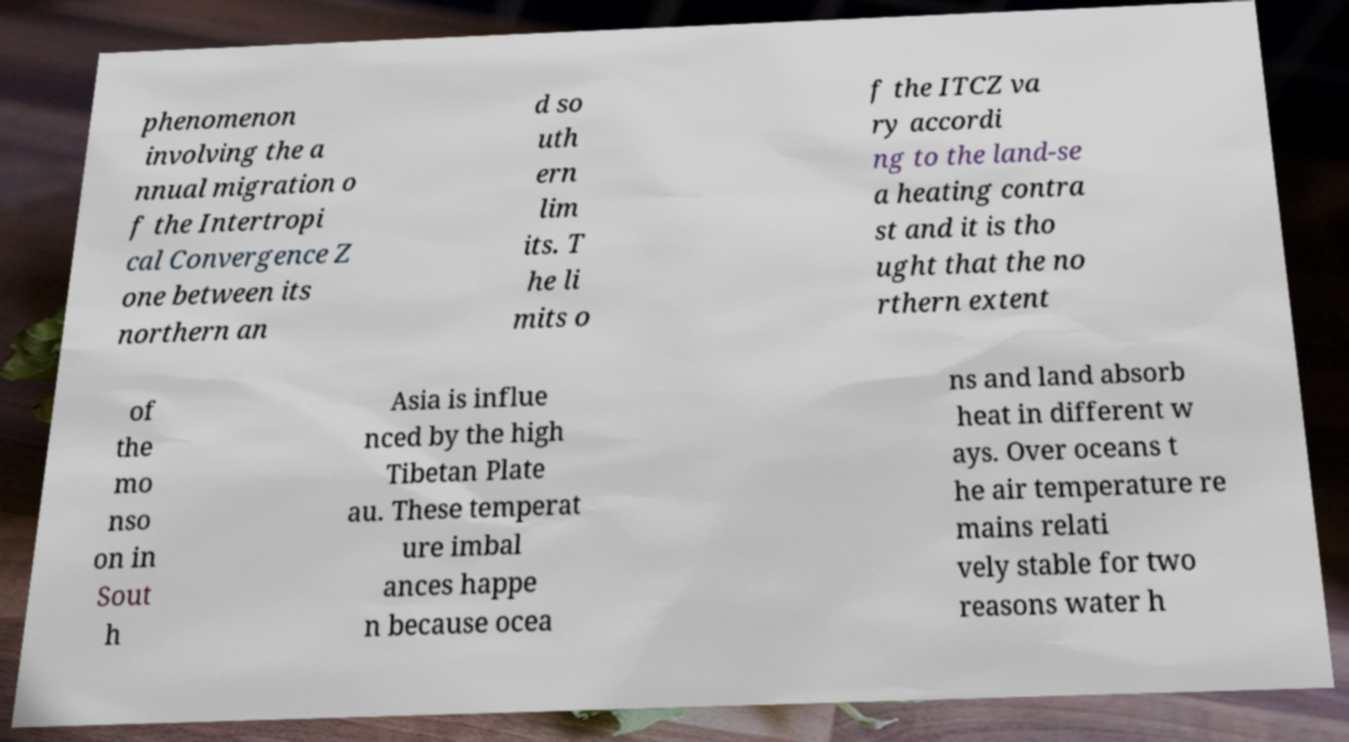Can you accurately transcribe the text from the provided image for me? phenomenon involving the a nnual migration o f the Intertropi cal Convergence Z one between its northern an d so uth ern lim its. T he li mits o f the ITCZ va ry accordi ng to the land-se a heating contra st and it is tho ught that the no rthern extent of the mo nso on in Sout h Asia is influe nced by the high Tibetan Plate au. These temperat ure imbal ances happe n because ocea ns and land absorb heat in different w ays. Over oceans t he air temperature re mains relati vely stable for two reasons water h 